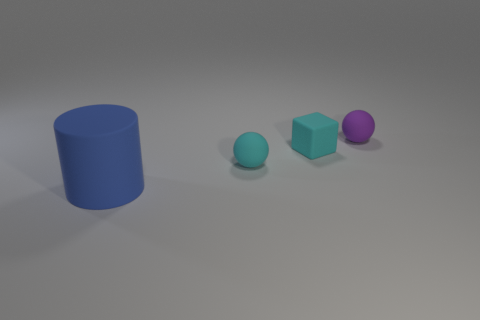Add 1 purple matte spheres. How many objects exist? 5 Subtract all blocks. How many objects are left? 3 Subtract 1 cyan cubes. How many objects are left? 3 Subtract all brown cubes. Subtract all rubber blocks. How many objects are left? 3 Add 2 cyan rubber things. How many cyan rubber things are left? 4 Add 2 small matte cylinders. How many small matte cylinders exist? 2 